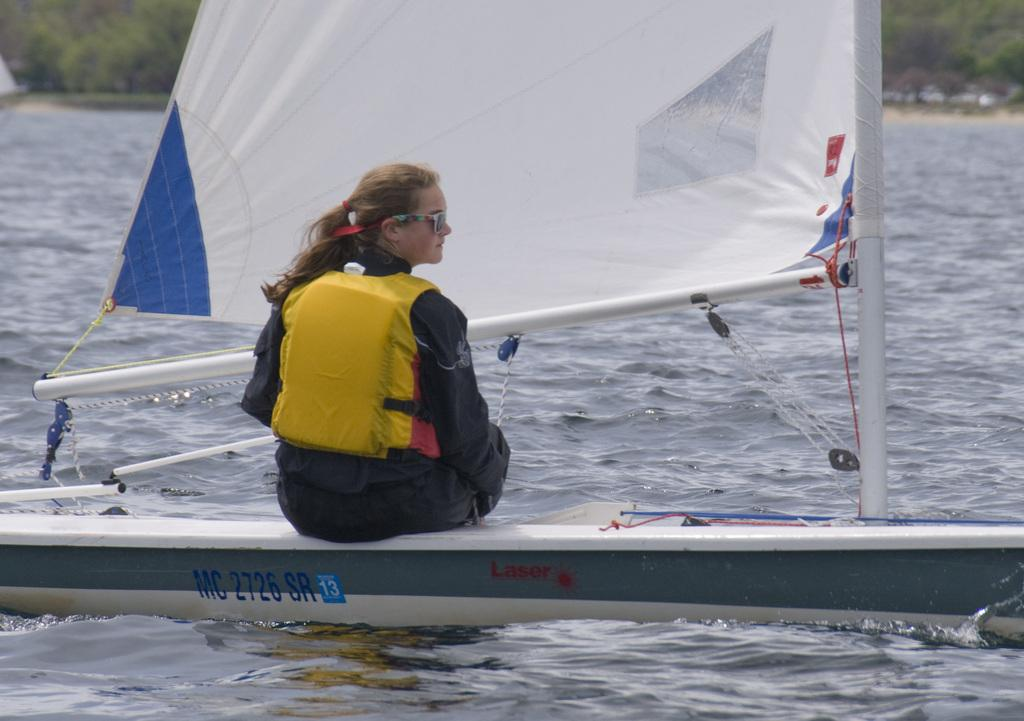What is the main subject in the center of the image? There is a boat in the center of the image. Is there anyone on the boat? Yes, a person is sitting on the boat. What is the boat doing in the image? The boat is sailing on the water. What can be seen in the background of the image? There are trees in the background of the image. Is there any text visible on the boat? Yes, there is text written on the boat. Where is the library located in the image? There is no library present in the image. What type of play is being performed on the boat? There is no play being performed on the boat; it is simply sailing on the water. 